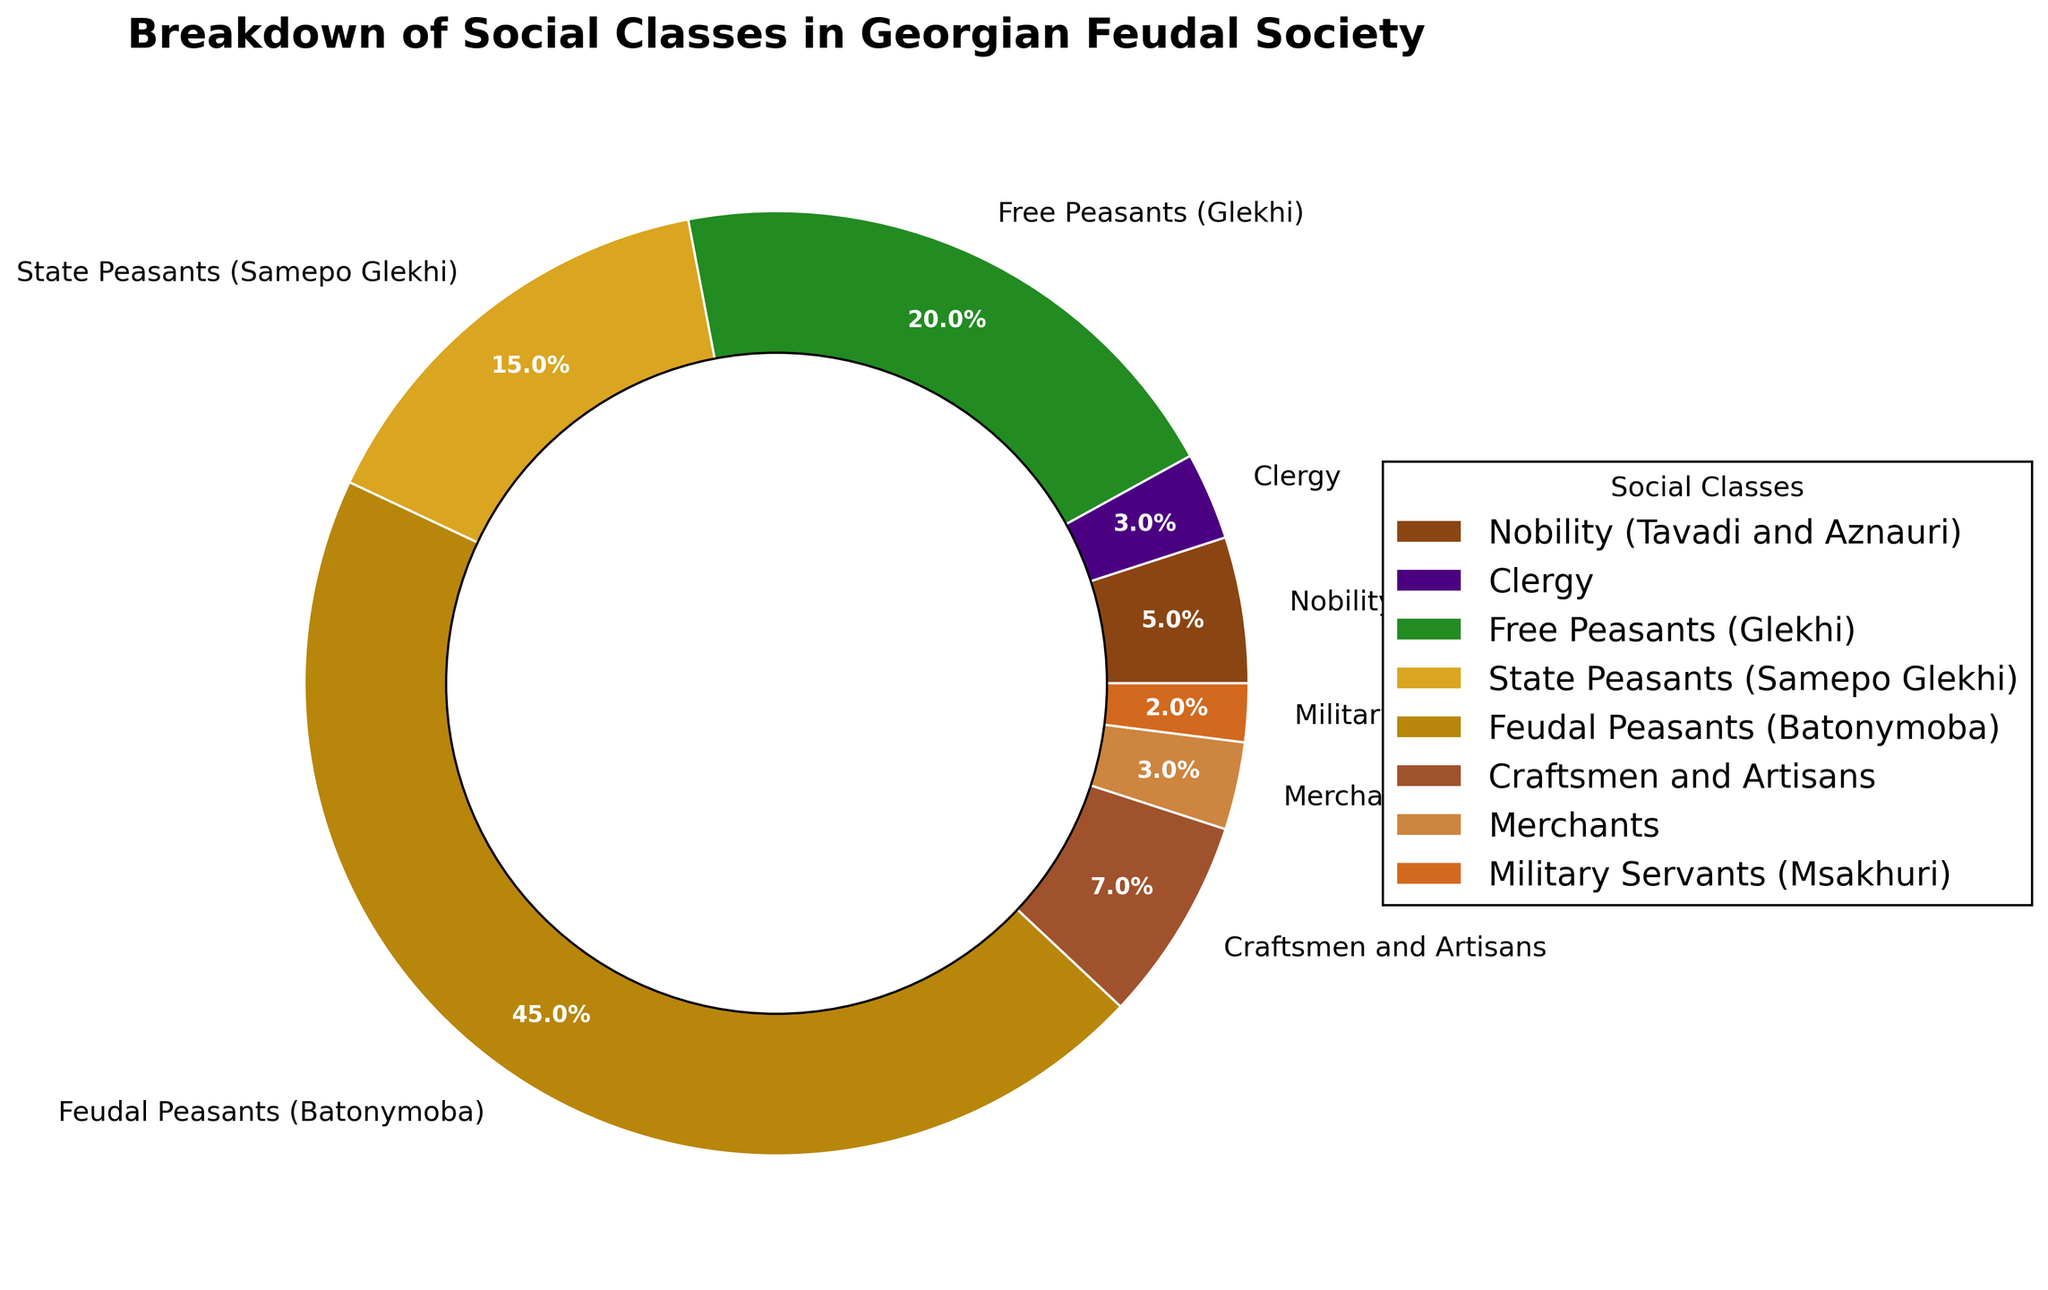Which social class constitutes the smallest percentage of Georgian feudal society? By looking at the pie chart, we can identify the smallest section. The Military Servants (Msakhuri) occupy the smallest slice of the pie, which is labeled with 2%.
Answer: Military Servants (Msakhuri) What is the combined percentage of Free Peasants and State Peasants? The pie chart shows that Free Peasants (Glekhi) constitute 20% and State Peasants (Samepo Glekhi) constitute 15%. Adding these two values, 20% + 15% = 35%.
Answer: 35% Which social class has a slightly higher representation, Craftsmen and Artisans or Merchants? The pie chart indicates that Craftsmen and Artisans represent 7%, while Merchants represent 3%. 7% is more than 3%.
Answer: Craftsmen and Artisans How much larger is the percentage of Feudal Peasants compared to Nobility? Feudal Peasants (Batonymoba) make up 45% and Nobility (Tavadi and Aznauri) make up 5%. The difference is calculated as 45% - 5% = 40%.
Answer: 40% What is the difference in percentage between the Clergy and Merchants? The pie chart shows the Clergy constitutes 3% and Merchants also constitute 3%. The difference between them is 3% - 3% = 0%.
Answer: 0% Which color represents the Clergy in the pie chart? In the pie chart, the color assigned to each social class is visual. The color for Clergy is the second color in the legend, which is purple.
Answer: Purple What is the percentage of people in Georgian feudal society not belonging to any peasant class? The pie chart lists non-peasant classes: Nobility (5%), Clergy (3%), Craftsmen and Artisans (7%), Merchants (3%), and Military Servants (2%). Summing these values, 5% + 3% + 7% + 3% + 2% = 20%.
Answer: 20% How do Nobility and Clergy combined compare to the percentage of Craftsmen and Artisans? Nobility (5%) and Clergy (3%) together make up 5% + 3% = 8%. Craftsmen and Artisans constitute 7%. Therefore, 8% is greater than 7%.
Answer: Greater What percentage of the society is made up of peasants in general? Total peasant classes include Free Peasants (20%), State Peasants (15%), and Feudal Peasants (45%). Summing these values, 20% + 15% + 45% = 80%.
Answer: 80% Which two social classes contribute an equal percentage to the overall distribution? The pie chart shows that both the Clergy and Merchants represent 3% of the society.
Answer: Clergy and Merchants 